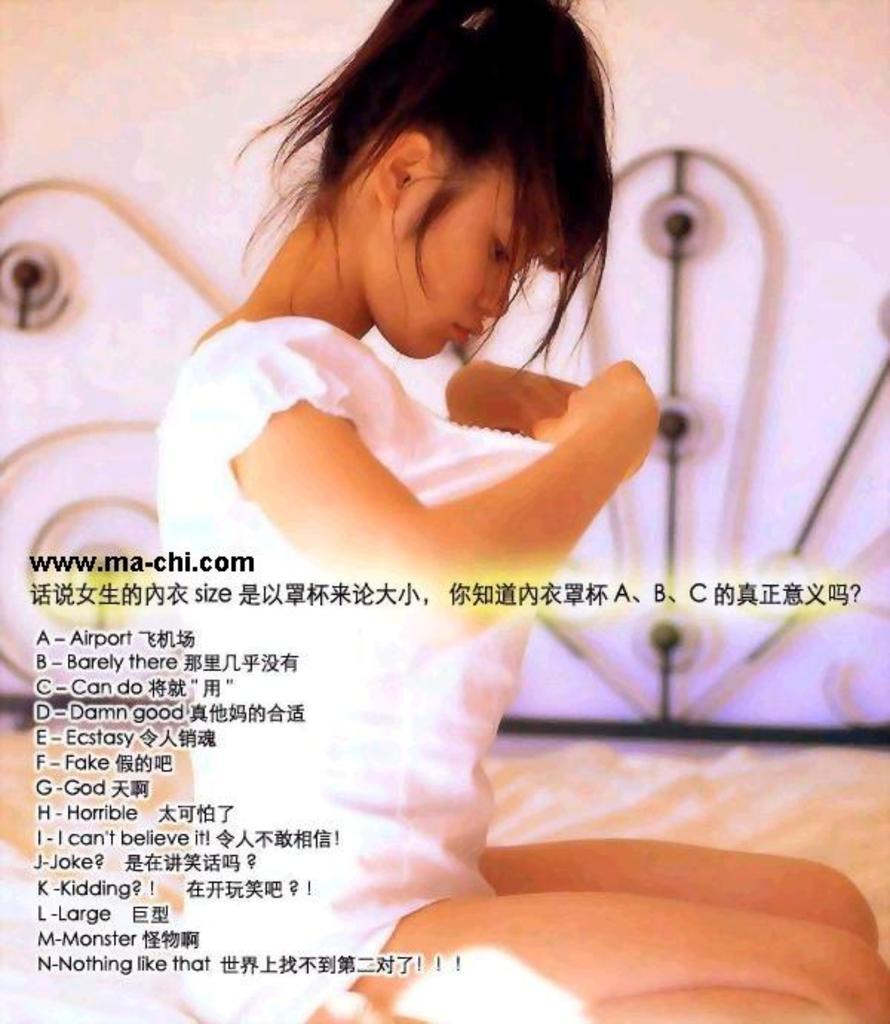Who is the main subject in the image? There is a woman in the image. What is the woman wearing? The woman is wearing a white dress. Where is the woman located in the image? The woman is sitting on a bed. What type of bear can be seen playing with a string in the image? There is no bear or string present in the image; it features a woman sitting on a bed wearing a white dress. 